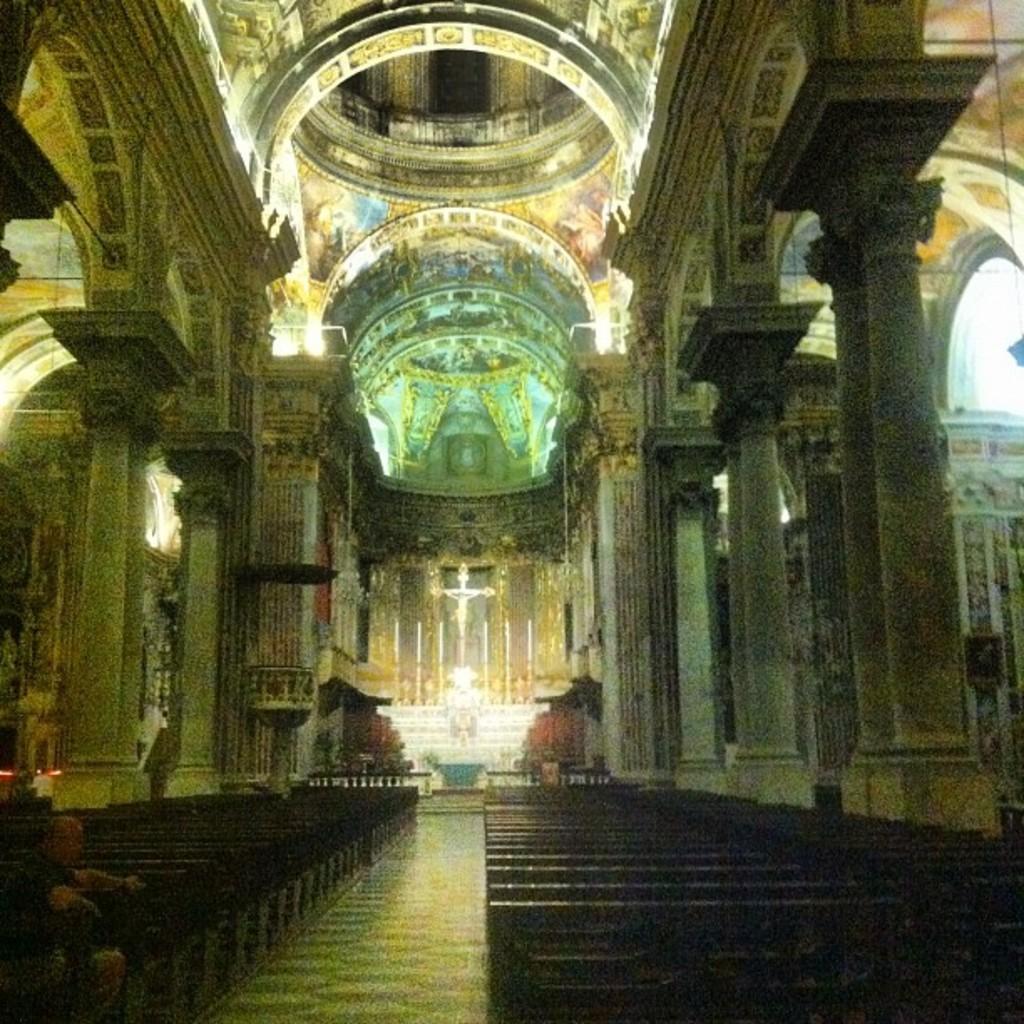In one or two sentences, can you explain what this image depicts? In this picture, we can see a man is sitting on a bench and in front of the man there are pillars, lights and other things. 